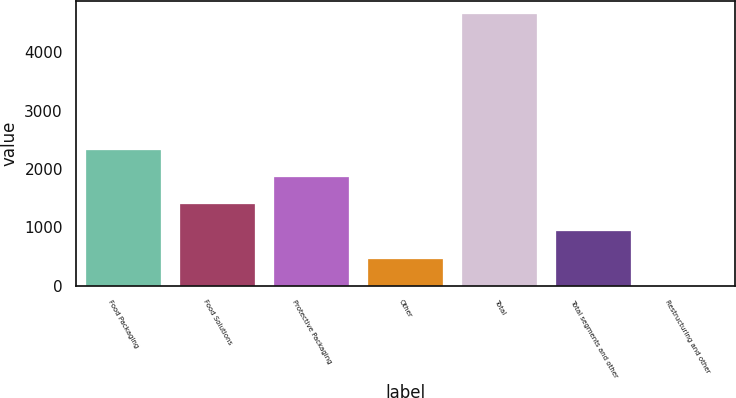<chart> <loc_0><loc_0><loc_500><loc_500><bar_chart><fcel>Food Packaging<fcel>Food Solutions<fcel>Protective Packaging<fcel>Other<fcel>Total<fcel>Total segments and other<fcel>Restructuring and other<nl><fcel>2326.4<fcel>1396.48<fcel>1861.44<fcel>466.56<fcel>4651.2<fcel>931.52<fcel>1.6<nl></chart> 